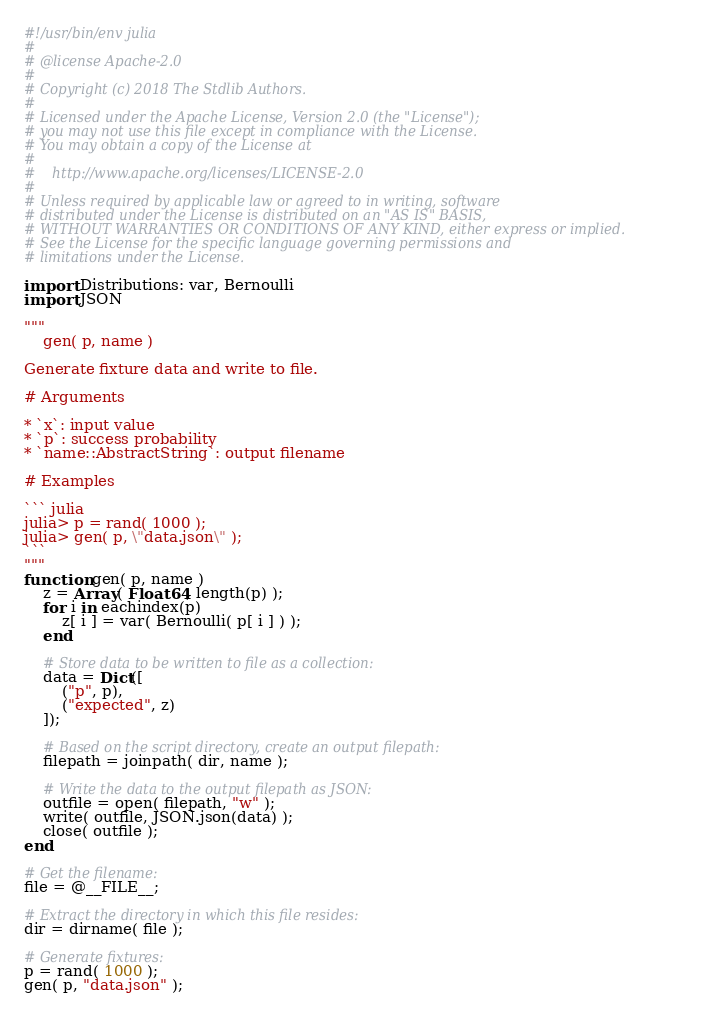Convert code to text. <code><loc_0><loc_0><loc_500><loc_500><_Julia_>#!/usr/bin/env julia
#
# @license Apache-2.0
#
# Copyright (c) 2018 The Stdlib Authors.
#
# Licensed under the Apache License, Version 2.0 (the "License");
# you may not use this file except in compliance with the License.
# You may obtain a copy of the License at
#
#    http://www.apache.org/licenses/LICENSE-2.0
#
# Unless required by applicable law or agreed to in writing, software
# distributed under the License is distributed on an "AS IS" BASIS,
# WITHOUT WARRANTIES OR CONDITIONS OF ANY KIND, either express or implied.
# See the License for the specific language governing permissions and
# limitations under the License.

import Distributions: var, Bernoulli
import JSON

"""
	gen( p, name )

Generate fixture data and write to file.

# Arguments

* `x`: input value
* `p`: success probability
* `name::AbstractString`: output filename

# Examples

``` julia
julia> p = rand( 1000 );
julia> gen( p, \"data.json\" );
```
"""
function gen( p, name )
	z = Array( Float64, length(p) );
	for i in eachindex(p)
		z[ i ] = var( Bernoulli( p[ i ] ) );
	end

	# Store data to be written to file as a collection:
	data = Dict([
		("p", p),
		("expected", z)
	]);

	# Based on the script directory, create an output filepath:
	filepath = joinpath( dir, name );

	# Write the data to the output filepath as JSON:
	outfile = open( filepath, "w" );
	write( outfile, JSON.json(data) );
	close( outfile );
end

# Get the filename:
file = @__FILE__;

# Extract the directory in which this file resides:
dir = dirname( file );

# Generate fixtures:
p = rand( 1000 );
gen( p, "data.json" );

</code> 